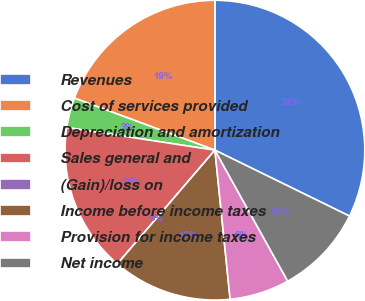Convert chart. <chart><loc_0><loc_0><loc_500><loc_500><pie_chart><fcel>Revenues<fcel>Cost of services provided<fcel>Depreciation and amortization<fcel>Sales general and<fcel>(Gain)/loss on<fcel>Income before income taxes<fcel>Provision for income taxes<fcel>Net income<nl><fcel>32.25%<fcel>19.35%<fcel>3.23%<fcel>16.13%<fcel>0.0%<fcel>12.9%<fcel>6.45%<fcel>9.68%<nl></chart> 